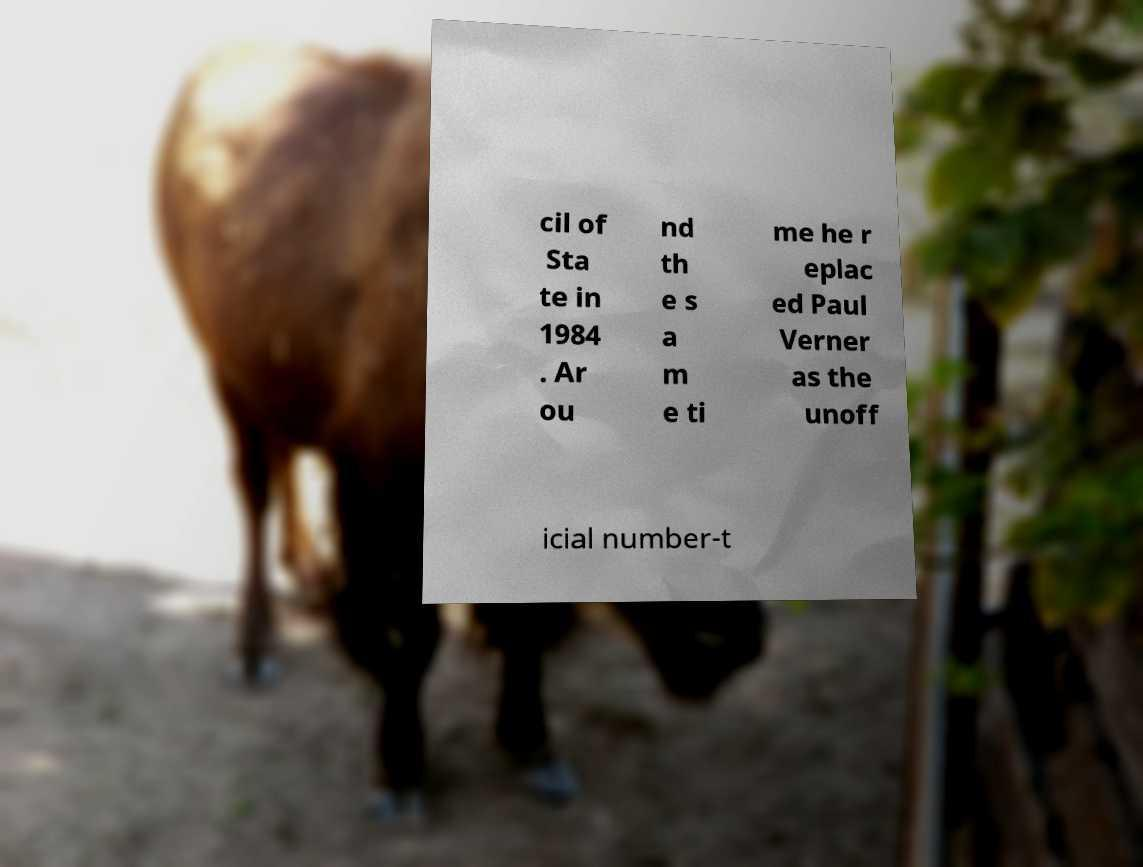Could you extract and type out the text from this image? cil of Sta te in 1984 . Ar ou nd th e s a m e ti me he r eplac ed Paul Verner as the unoff icial number-t 